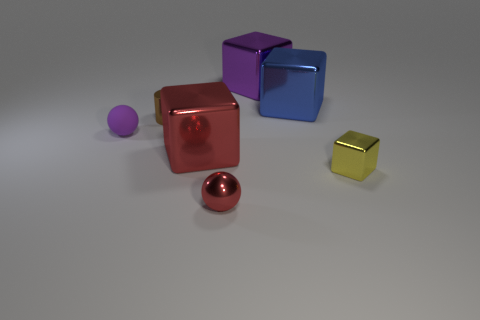Imagine these objects are part of a story. What role could they play? In the realm of imagination, these objects could represent characters or important artifacts in a story. The spheres might be mystical orbs holding secret powers, while the cubes could be containers for magical substances or ancient puzzle boxes hiding treasures within. 